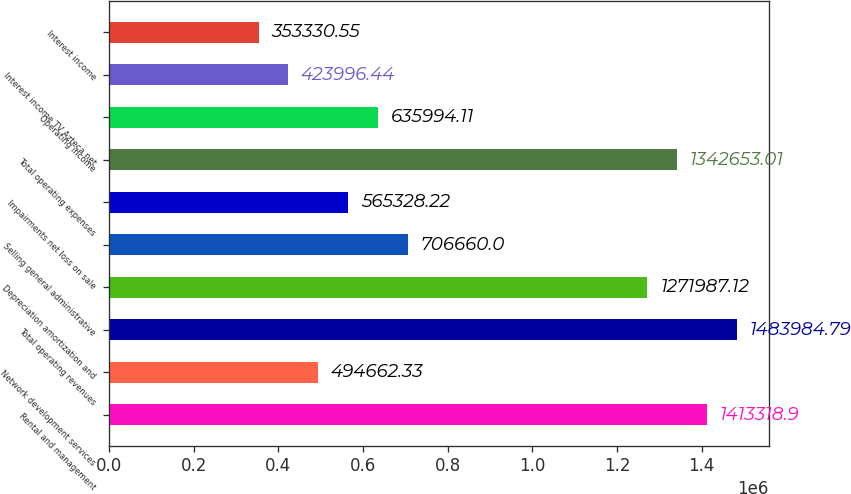Convert chart. <chart><loc_0><loc_0><loc_500><loc_500><bar_chart><fcel>Rental and management<fcel>Network development services<fcel>Total operating revenues<fcel>Depreciation amortization and<fcel>Selling general administrative<fcel>Impairments net loss on sale<fcel>Total operating expenses<fcel>Operating income<fcel>Interest income TV Azteca net<fcel>Interest income<nl><fcel>1.41332e+06<fcel>494662<fcel>1.48398e+06<fcel>1.27199e+06<fcel>706660<fcel>565328<fcel>1.34265e+06<fcel>635994<fcel>423996<fcel>353331<nl></chart> 